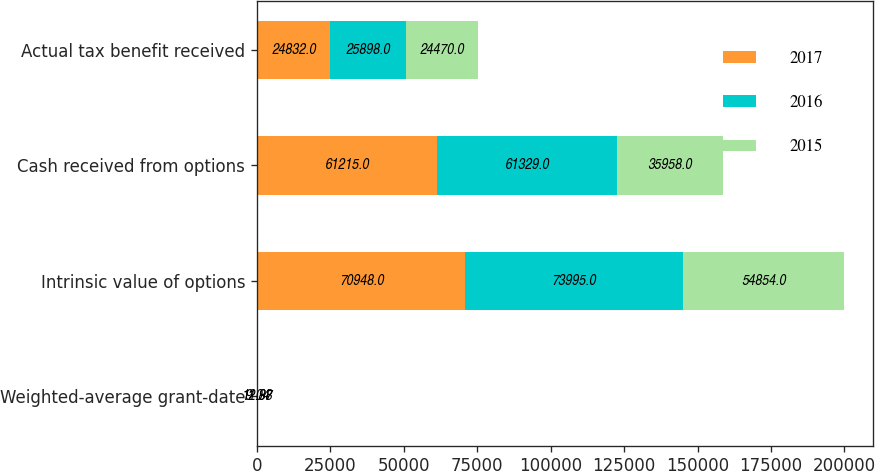Convert chart to OTSL. <chart><loc_0><loc_0><loc_500><loc_500><stacked_bar_chart><ecel><fcel>Weighted-average grant-date<fcel>Intrinsic value of options<fcel>Cash received from options<fcel>Actual tax benefit received<nl><fcel>2017<fcel>12.88<fcel>70948<fcel>61215<fcel>24832<nl><fcel>2016<fcel>9.04<fcel>73995<fcel>61329<fcel>25898<nl><fcel>2015<fcel>11.97<fcel>54854<fcel>35958<fcel>24470<nl></chart> 